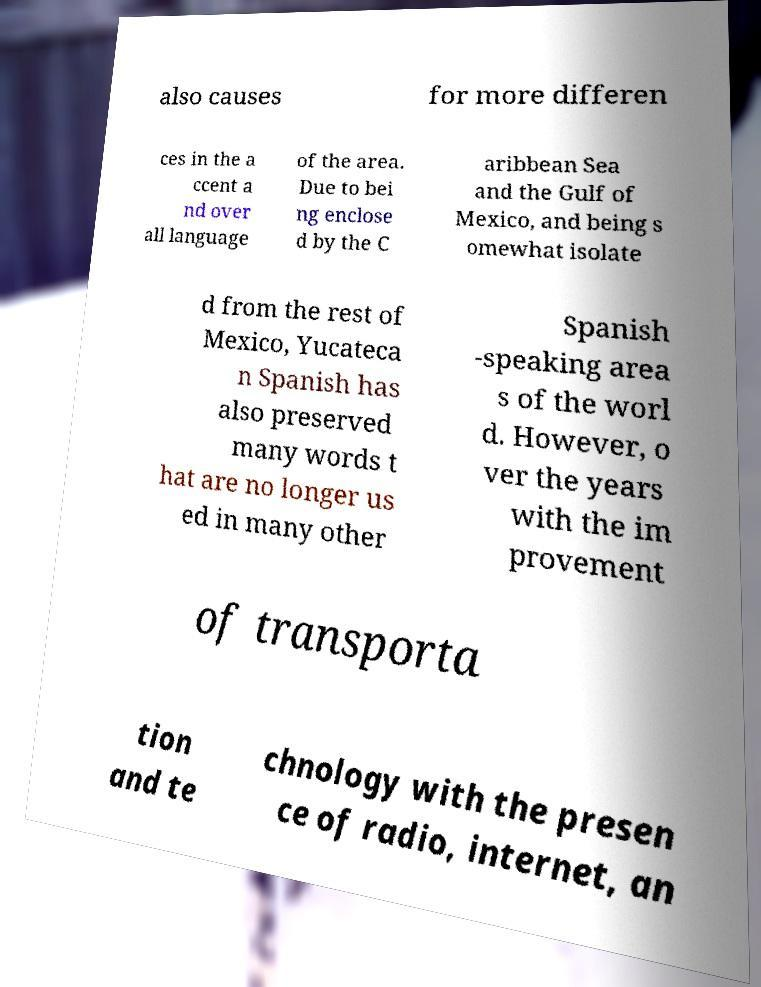There's text embedded in this image that I need extracted. Can you transcribe it verbatim? also causes for more differen ces in the a ccent a nd over all language of the area. Due to bei ng enclose d by the C aribbean Sea and the Gulf of Mexico, and being s omewhat isolate d from the rest of Mexico, Yucateca n Spanish has also preserved many words t hat are no longer us ed in many other Spanish -speaking area s of the worl d. However, o ver the years with the im provement of transporta tion and te chnology with the presen ce of radio, internet, an 